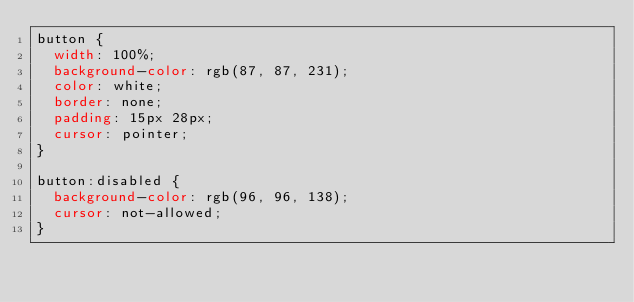<code> <loc_0><loc_0><loc_500><loc_500><_CSS_>button {
  width: 100%;
  background-color: rgb(87, 87, 231);
  color: white;
  border: none;
  padding: 15px 28px;
  cursor: pointer;
}

button:disabled {
  background-color: rgb(96, 96, 138);
  cursor: not-allowed;
}
</code> 